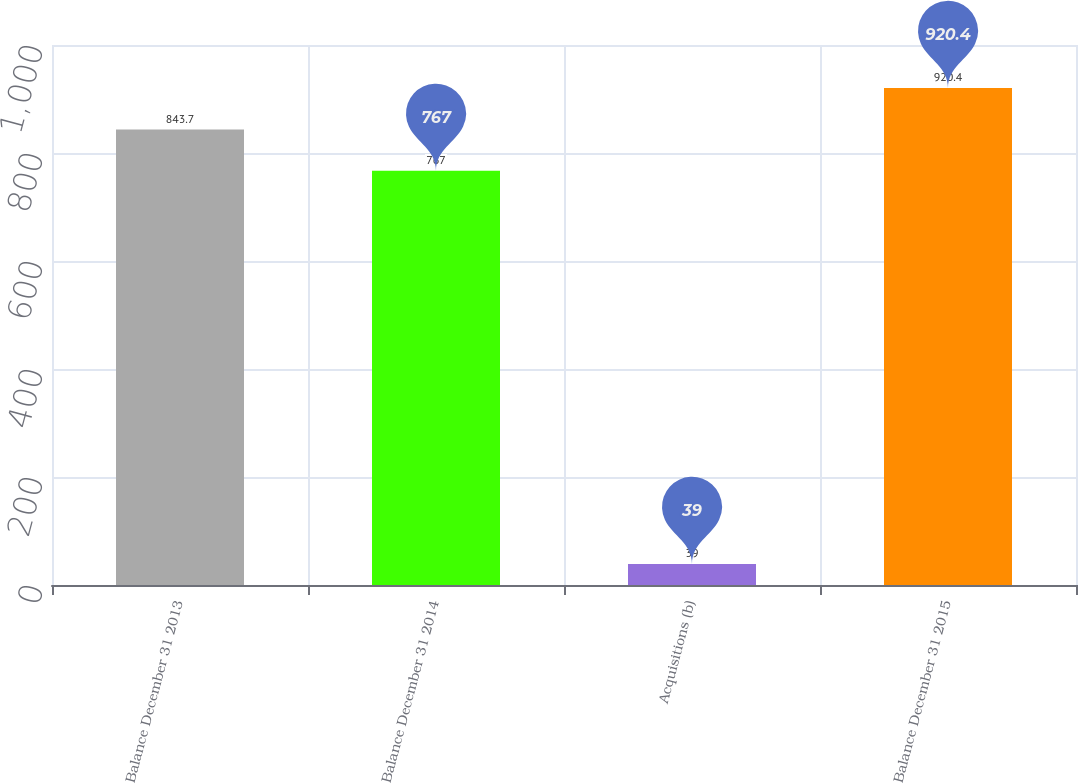Convert chart to OTSL. <chart><loc_0><loc_0><loc_500><loc_500><bar_chart><fcel>Balance December 31 2013<fcel>Balance December 31 2014<fcel>Acquisitions (b)<fcel>Balance December 31 2015<nl><fcel>843.7<fcel>767<fcel>39<fcel>920.4<nl></chart> 